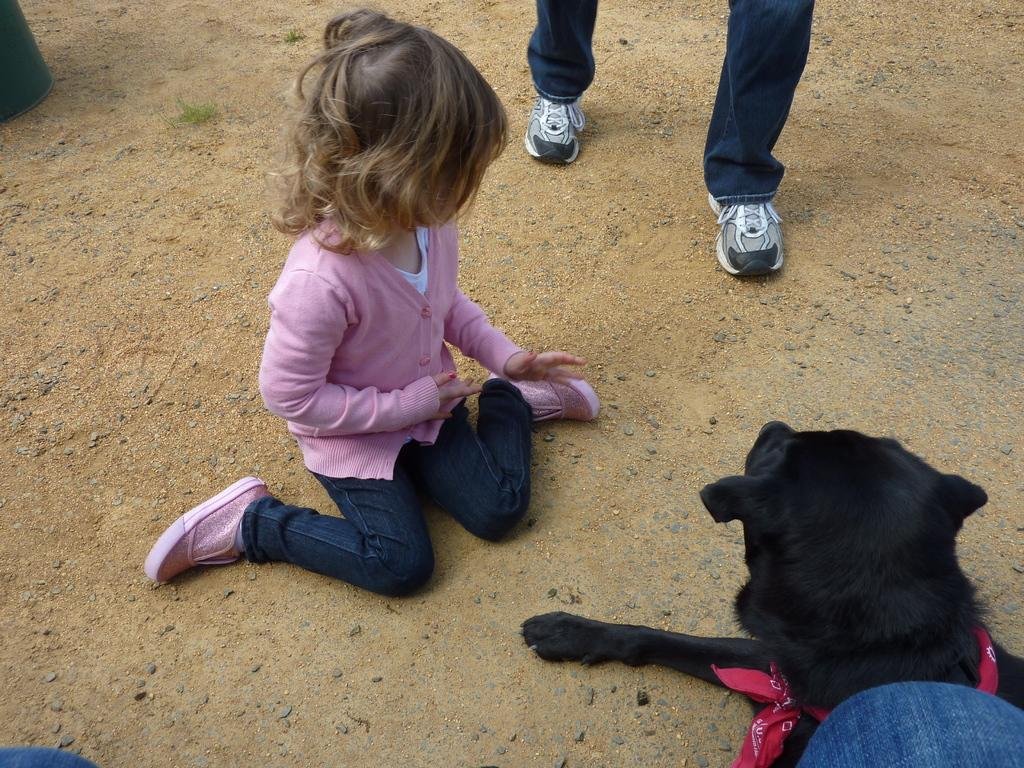Who is the main subject in the image? There is a girl in the image. What is the girl wearing? The girl is wearing trousers and shoes. Can you describe the girl's hairstyle? The girl has short hair. What other living creature can be seen in the image? There is a dog on the right side of the image. Where is the person located in the image? There is a person in the middle of the image. What color is the paint on the squirrel's tail in the image? There is no squirrel present in the image, and therefore no paint on its tail. How many brothers does the girl have in the image? The provided facts do not mention any brothers, so we cannot determine the number of brothers the girl has in the image. 